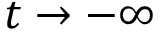<formula> <loc_0><loc_0><loc_500><loc_500>t \rightarrow - \infty</formula> 